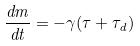Convert formula to latex. <formula><loc_0><loc_0><loc_500><loc_500>\frac { d m } { d t } = - \gamma ( \tau + \tau _ { d } )</formula> 